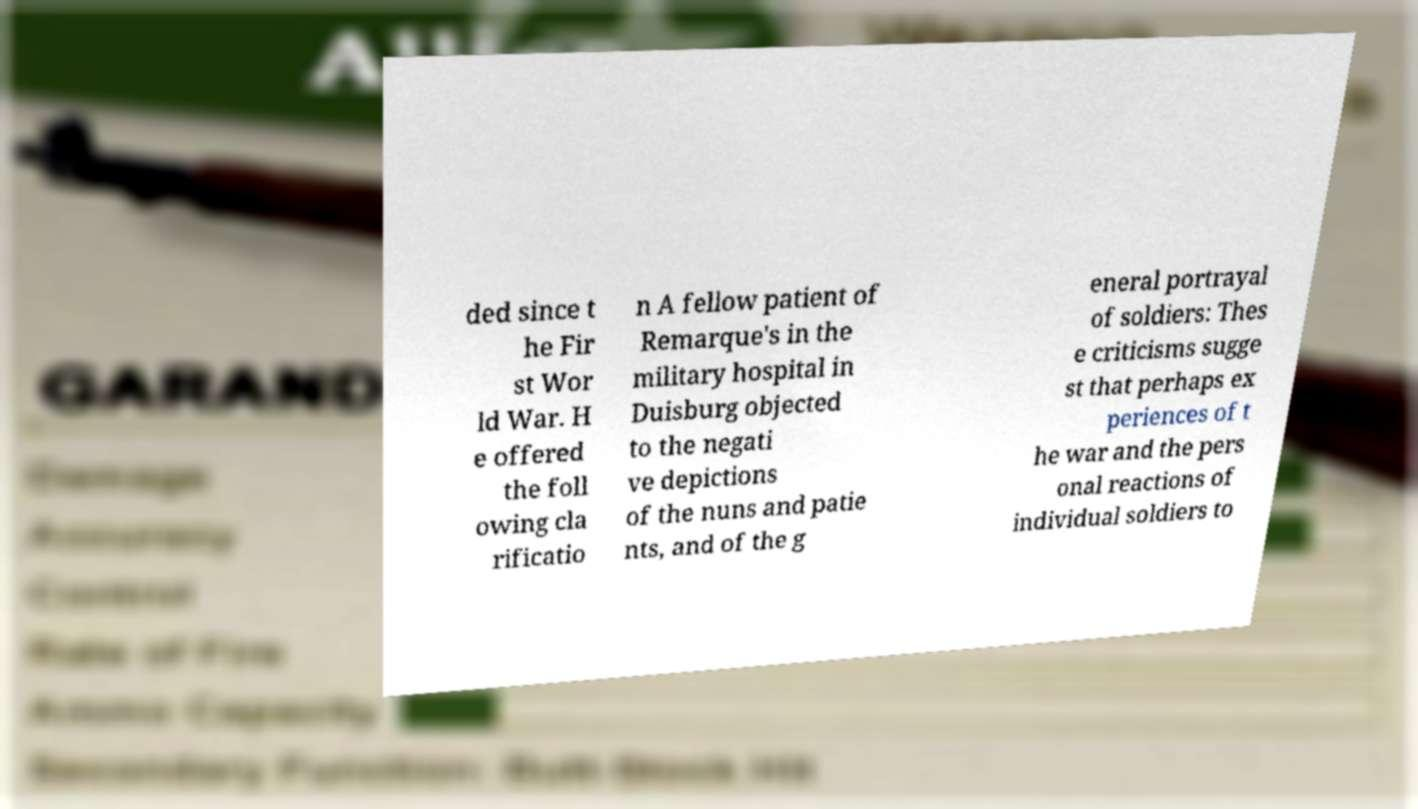Could you extract and type out the text from this image? ded since t he Fir st Wor ld War. H e offered the foll owing cla rificatio n A fellow patient of Remarque's in the military hospital in Duisburg objected to the negati ve depictions of the nuns and patie nts, and of the g eneral portrayal of soldiers: Thes e criticisms sugge st that perhaps ex periences of t he war and the pers onal reactions of individual soldiers to 